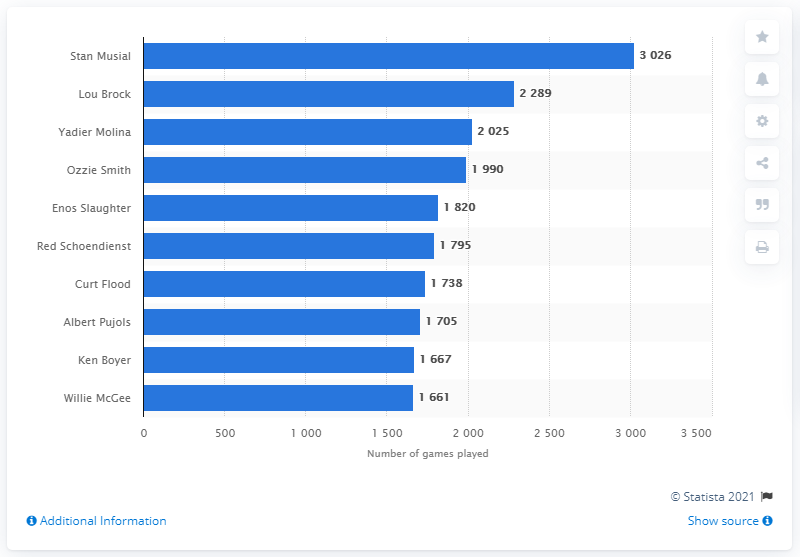Specify some key components in this picture. Stan Musial, the iconic St. Louis Cardinals player, holds the record for the most games played in franchise history. 